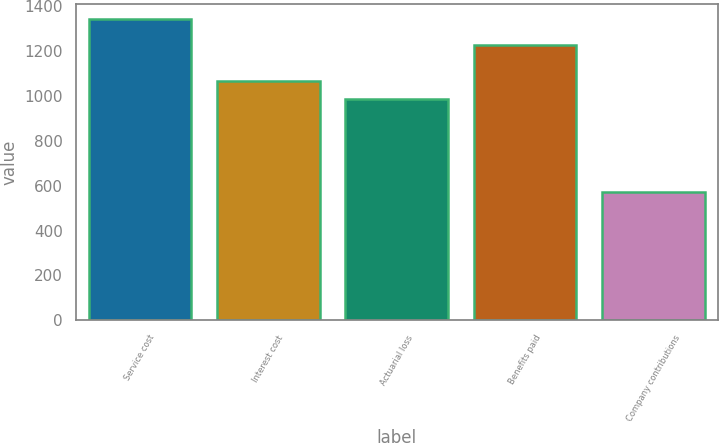Convert chart to OTSL. <chart><loc_0><loc_0><loc_500><loc_500><bar_chart><fcel>Service cost<fcel>Interest cost<fcel>Actuarial loss<fcel>Benefits paid<fcel>Company contributions<nl><fcel>1341<fcel>1064.1<fcel>987<fcel>1226<fcel>570<nl></chart> 